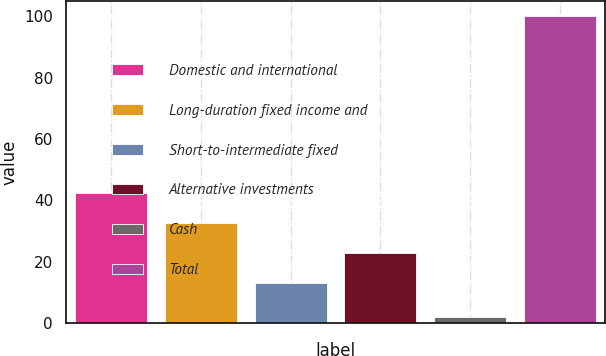<chart> <loc_0><loc_0><loc_500><loc_500><bar_chart><fcel>Domestic and international<fcel>Long-duration fixed income and<fcel>Short-to-intermediate fixed<fcel>Alternative investments<fcel>Cash<fcel>Total<nl><fcel>42.4<fcel>32.6<fcel>13<fcel>22.8<fcel>2<fcel>100<nl></chart> 